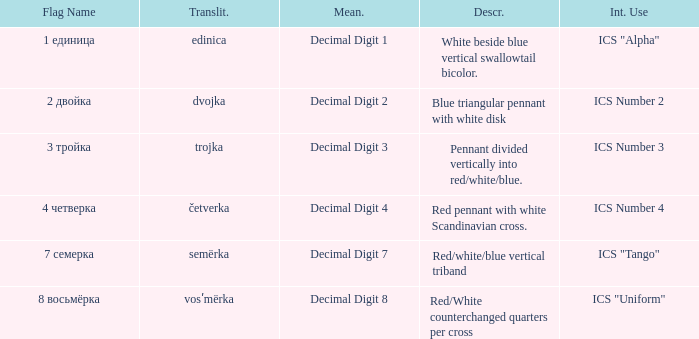Give me the full table as a dictionary. {'header': ['Flag Name', 'Translit.', 'Mean.', 'Descr.', 'Int. Use'], 'rows': [['1 единица', 'edinica', 'Decimal Digit 1', 'White beside blue vertical swallowtail bicolor.', 'ICS "Alpha"'], ['2 двойка', 'dvojka', 'Decimal Digit 2', 'Blue triangular pennant with white disk', 'ICS Number 2'], ['3 тройка', 'trojka', 'Decimal Digit 3', 'Pennant divided vertically into red/white/blue.', 'ICS Number 3'], ['4 четверка', 'četverka', 'Decimal Digit 4', 'Red pennant with white Scandinavian cross.', 'ICS Number 4'], ['7 семерка', 'semërka', 'Decimal Digit 7', 'Red/white/blue vertical triband', 'ICS "Tango"'], ['8 восьмёрка', 'vosʹmërka', 'Decimal Digit 8', 'Red/White counterchanged quarters per cross', 'ICS "Uniform"']]} What is the international use of the 1 единица flag? ICS "Alpha". 